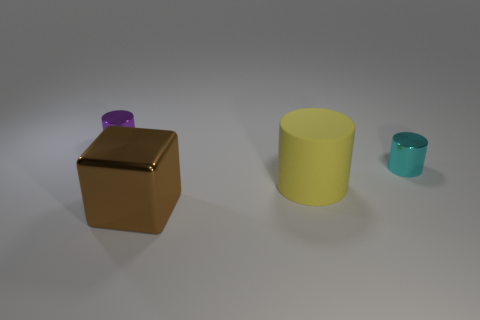Add 3 tiny purple metal objects. How many objects exist? 7 Subtract all purple cylinders. How many cylinders are left? 2 Subtract all cubes. How many objects are left? 3 Subtract all purple metal objects. Subtract all large brown shiny blocks. How many objects are left? 2 Add 2 small metallic cylinders. How many small metallic cylinders are left? 4 Add 1 large objects. How many large objects exist? 3 Subtract 0 cyan spheres. How many objects are left? 4 